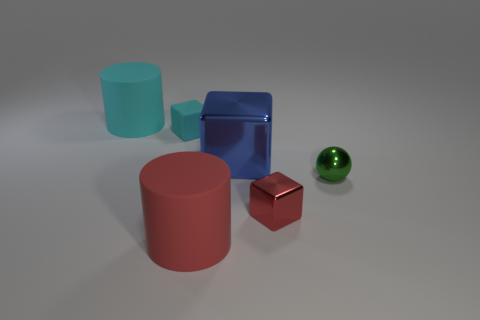What color is the small cube right of the large red thing?
Keep it short and to the point. Red. What number of other objects are there of the same size as the green metallic thing?
Give a very brief answer. 2. What is the size of the object that is on the left side of the large blue cube and in front of the tiny cyan block?
Offer a terse response. Large. There is a small matte cube; does it have the same color as the big rubber cylinder on the right side of the cyan cylinder?
Offer a very short reply. No. Is there a tiny cyan rubber object of the same shape as the blue metallic object?
Give a very brief answer. Yes. What number of objects are either metallic spheres or red rubber cylinders that are in front of the big cyan matte cylinder?
Your answer should be compact. 2. How many other objects are the same material as the ball?
Provide a succinct answer. 2. What number of things are tiny red objects or cyan rubber objects?
Ensure brevity in your answer.  3. Are there more large things right of the tiny green metal object than large red cylinders right of the big red matte cylinder?
Your answer should be very brief. No. There is a tiny block that is behind the red shiny block; does it have the same color as the big rubber cylinder in front of the large cyan cylinder?
Give a very brief answer. No. 